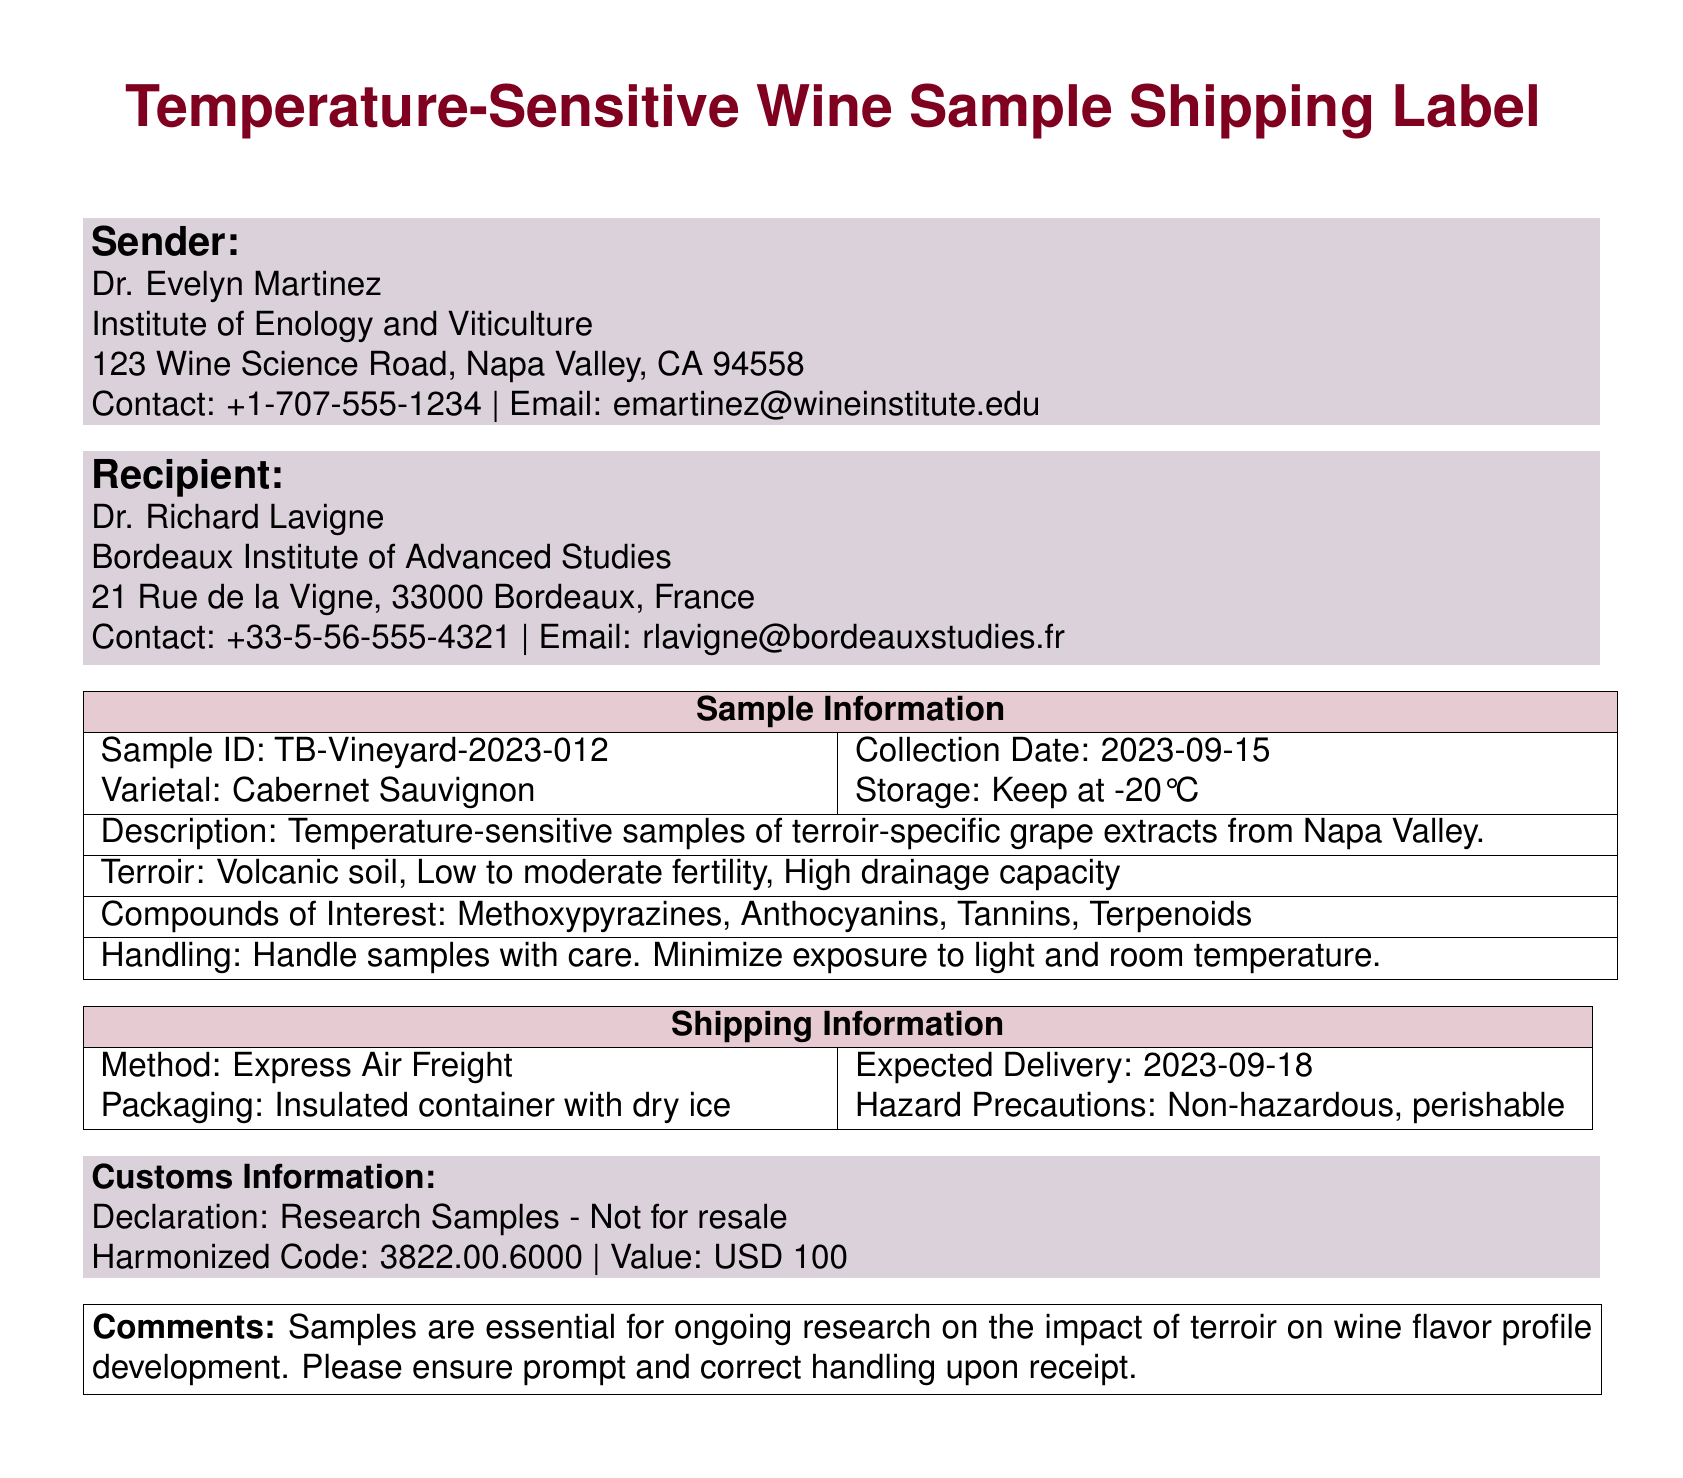What is the sender's name? The sender of the samples is Dr. Evelyn Martinez, listed at the top of the shipping label.
Answer: Dr. Evelyn Martinez What is the expected delivery date? The expected delivery date is indicated in the shipping information section of the document.
Answer: 2023-09-18 What is the varietal of the grape extract? The varietal is specified in the sample information section on the shipping label.
Answer: Cabernet Sauvignon What are the compounds of interest? The compounds listed in the document are found within the sample information section.
Answer: Methoxypyrazines, Anthocyanins, Tannins, Terpenoids What is the storage temperature for the samples? The required storage temperature is mentioned in the sample information section.
Answer: -20°C What is the packaging used for shipping? The packaging details are outlined in the shipping information section.
Answer: Insulated container with dry ice Why are these samples important? The significance of the samples is addressed in the comments section of the document.
Answer: Impact of terroir on wine flavor profile development What is the contact number for the recipient? The contact number is provided for the recipient in the shipping label.
Answer: +33-5-56-555-4321 